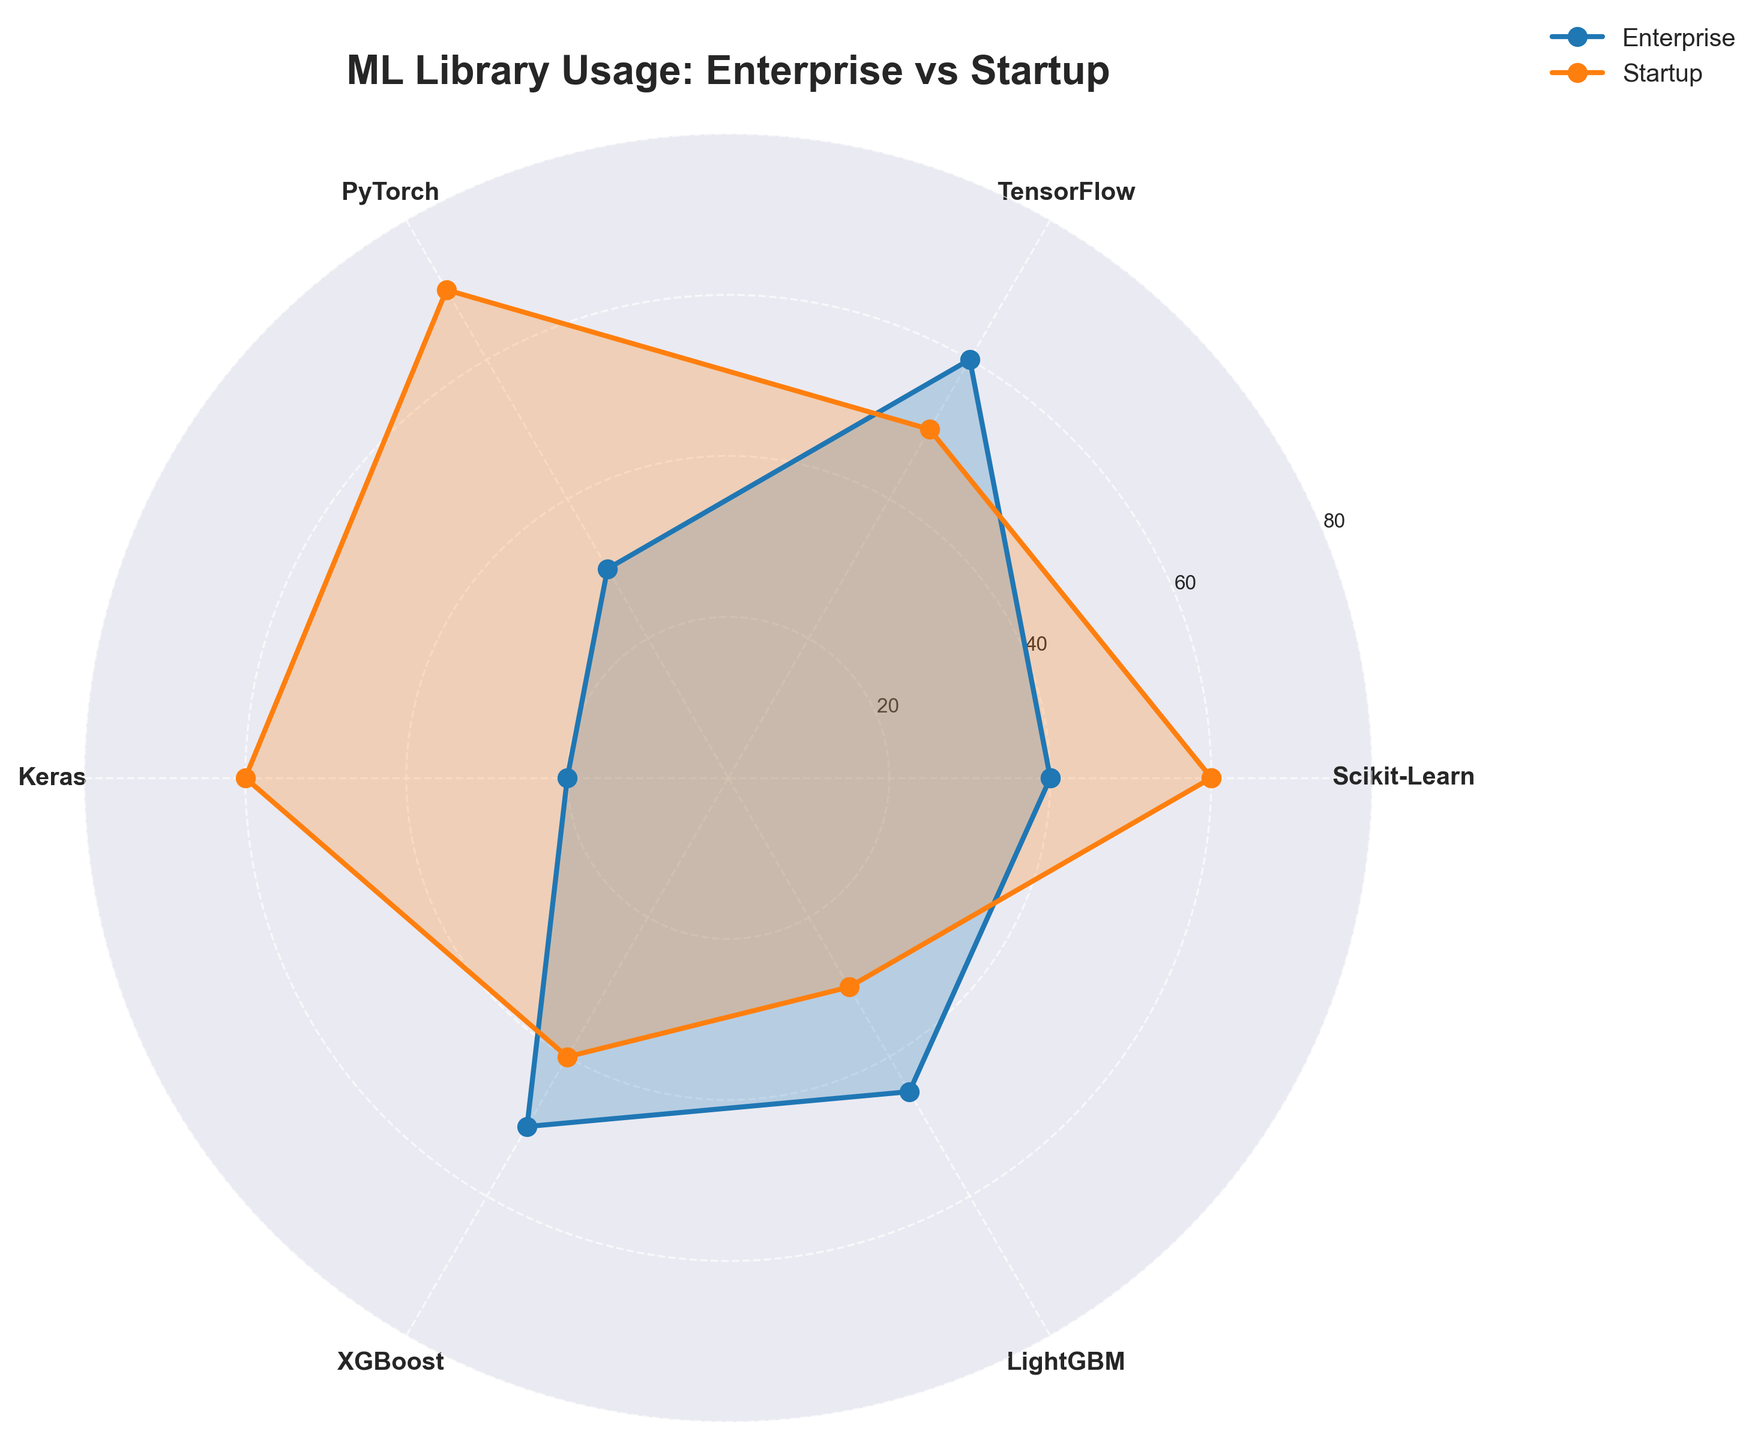What's the title of the chart? The title of the chart is displayed at the top center of the figure. It reads "ML Library Usage: Enterprise vs Startup".
Answer: ML Library Usage: Enterprise vs Startup What ML library reports the highest usage in startups? To determine this, look at the highest data point in the 'Startup' line on the Polar Chart. PyTorch has the highest usage value at 70.
Answer: PyTorch Which environment shows higher usage of Scikit-Learn? By comparing the Scikit-Learn data points for both environments, we see that the Startup environment usage is 60 while the Enterprise environment usage is 40. Startups show higher usage of Scikit-Learn.
Answer: Startup What's the combined usage of TensorFlow in both environments? Add the TensorFlow values for both Enterprise and Startup environments. TensorFlow usage is 60 in Enterprise and 50 in Startup, giving a total of 110.
Answer: 110 Compare the usage of LightGBM in Enterprise and Startup environments. Look at the LightGBM data points for both categories. Enterprise usage is 45, while Startup usage is 30. Therefore, Enterprise usage is higher than Startup usage by 15 points.
Answer: Enterprise How many libraries show higher usage in startups compared to enterprises? Check each library's usage value in both environments: Scikit-Learn (Startup: 60, Enterprise: 40), PyTorch (Startup: 70, Enterprise: 30), Keras (Startup: 60, Enterprise: 20). Therefore, three libraries have higher usage in Startups compared to Enterprises.
Answer: 3 What is the average usage of Keras across both environments? Add the Keras values for Enterprise (20) and Startup (60), and divide by 2. The average is (20 + 60) / 2 = 40.
Answer: 40 Which library has the smallest difference in usage between startups and enterprises? Calculate the absolute difference for each library: Scikit-Learn (60-40=20), TensorFlow (60-50=10), PyTorch (70-30=40), Keras (60-20=40), XGBoost (50-40=10), LightGBM (45-30=15). TensorFlow and XGBoost both have the smallest difference of 10.
Answer: TensorFlow and XGBoost What's the median usage value across all libraries in the enterprise environment? The usage values in the Enterprise environment are 40, 60, 30, 20, 50, and 45. Arrange them (20, 30, 40, 45, 50, 60). The median value (middle value) for these sorted figures is (40+45)/2 = 42.5.
Answer: 42.5 